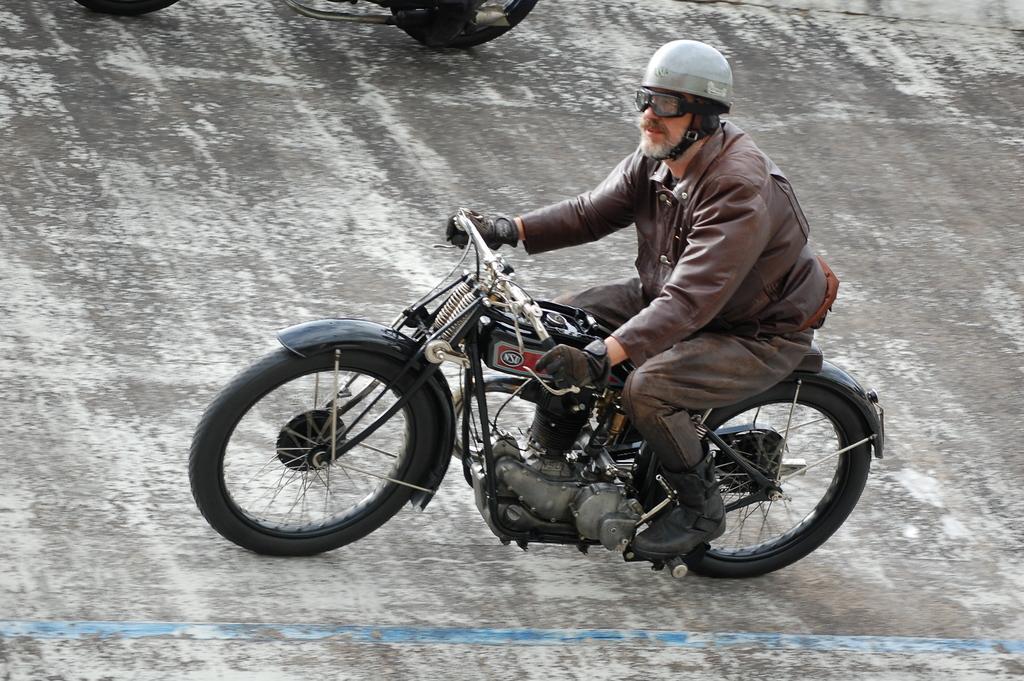Could you give a brief overview of what you see in this image? The image is taken on the road. In the center of the image there is a man who is wearing a jacket is riding a motorbike. 